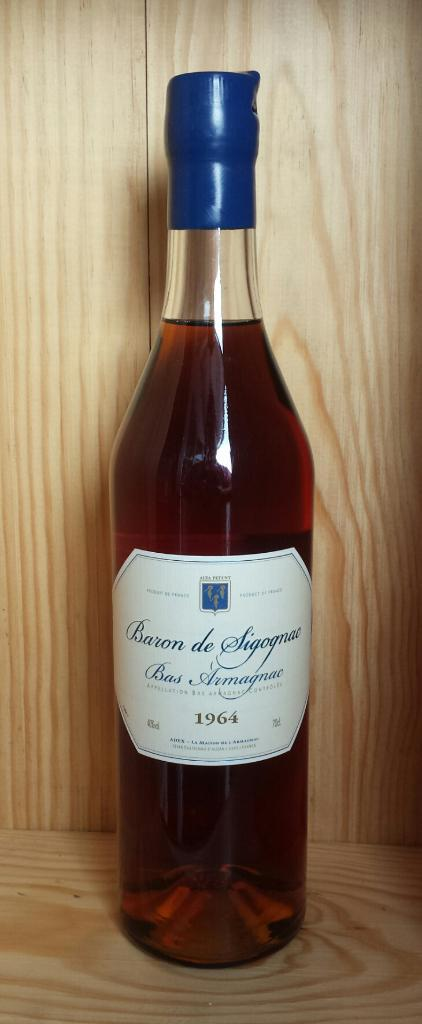<image>
Offer a succinct explanation of the picture presented. A bottle of Baron de Sigognac from 1964 sits on a wooden shelf. 